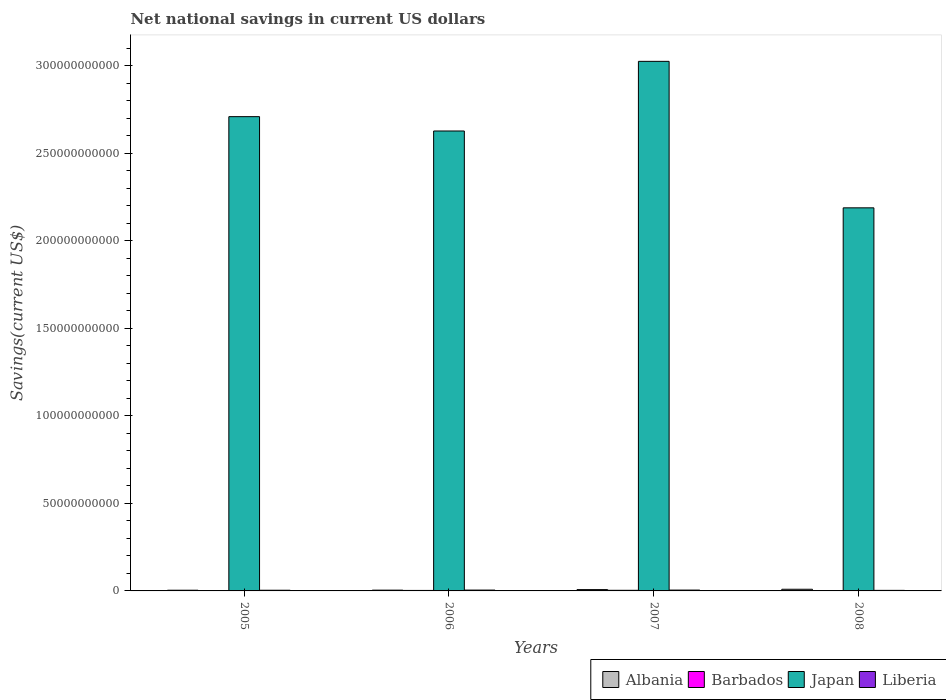How many different coloured bars are there?
Make the answer very short. 4. Are the number of bars per tick equal to the number of legend labels?
Offer a terse response. Yes. How many bars are there on the 1st tick from the left?
Give a very brief answer. 4. How many bars are there on the 3rd tick from the right?
Your answer should be very brief. 4. What is the label of the 3rd group of bars from the left?
Your response must be concise. 2007. In how many cases, is the number of bars for a given year not equal to the number of legend labels?
Your answer should be very brief. 0. What is the net national savings in Liberia in 2008?
Your answer should be very brief. 3.15e+08. Across all years, what is the maximum net national savings in Japan?
Offer a terse response. 3.03e+11. Across all years, what is the minimum net national savings in Albania?
Your response must be concise. 3.93e+08. What is the total net national savings in Japan in the graph?
Offer a terse response. 1.06e+12. What is the difference between the net national savings in Liberia in 2006 and that in 2007?
Offer a very short reply. 1.03e+06. What is the difference between the net national savings in Albania in 2007 and the net national savings in Liberia in 2006?
Your response must be concise. 2.70e+08. What is the average net national savings in Barbados per year?
Offer a terse response. 2.28e+08. In the year 2006, what is the difference between the net national savings in Barbados and net national savings in Liberia?
Your answer should be very brief. -1.98e+08. In how many years, is the net national savings in Japan greater than 160000000000 US$?
Ensure brevity in your answer.  4. What is the ratio of the net national savings in Japan in 2007 to that in 2008?
Your answer should be very brief. 1.38. Is the difference between the net national savings in Barbados in 2005 and 2007 greater than the difference between the net national savings in Liberia in 2005 and 2007?
Your answer should be compact. No. What is the difference between the highest and the second highest net national savings in Liberia?
Your response must be concise. 1.03e+06. What is the difference between the highest and the lowest net national savings in Albania?
Your response must be concise. 5.57e+08. What does the 3rd bar from the left in 2007 represents?
Offer a very short reply. Japan. What does the 1st bar from the right in 2005 represents?
Offer a very short reply. Liberia. Is it the case that in every year, the sum of the net national savings in Liberia and net national savings in Albania is greater than the net national savings in Barbados?
Make the answer very short. Yes. How many bars are there?
Ensure brevity in your answer.  16. How many years are there in the graph?
Provide a succinct answer. 4. What is the difference between two consecutive major ticks on the Y-axis?
Your response must be concise. 5.00e+1. Are the values on the major ticks of Y-axis written in scientific E-notation?
Your answer should be compact. No. Does the graph contain any zero values?
Offer a terse response. No. Does the graph contain grids?
Make the answer very short. No. Where does the legend appear in the graph?
Offer a very short reply. Bottom right. How many legend labels are there?
Give a very brief answer. 4. How are the legend labels stacked?
Your response must be concise. Horizontal. What is the title of the graph?
Make the answer very short. Net national savings in current US dollars. Does "Dominica" appear as one of the legend labels in the graph?
Ensure brevity in your answer.  No. What is the label or title of the X-axis?
Provide a short and direct response. Years. What is the label or title of the Y-axis?
Make the answer very short. Savings(current US$). What is the Savings(current US$) in Albania in 2005?
Offer a very short reply. 3.93e+08. What is the Savings(current US$) in Barbados in 2005?
Provide a short and direct response. 1.75e+08. What is the Savings(current US$) in Japan in 2005?
Offer a very short reply. 2.71e+11. What is the Savings(current US$) in Liberia in 2005?
Your response must be concise. 3.86e+08. What is the Savings(current US$) in Albania in 2006?
Provide a short and direct response. 4.37e+08. What is the Savings(current US$) in Barbados in 2006?
Your answer should be very brief. 2.84e+08. What is the Savings(current US$) of Japan in 2006?
Provide a short and direct response. 2.63e+11. What is the Savings(current US$) in Liberia in 2006?
Offer a very short reply. 4.81e+08. What is the Savings(current US$) of Albania in 2007?
Keep it short and to the point. 7.51e+08. What is the Savings(current US$) in Barbados in 2007?
Offer a terse response. 3.56e+08. What is the Savings(current US$) of Japan in 2007?
Give a very brief answer. 3.03e+11. What is the Savings(current US$) of Liberia in 2007?
Make the answer very short. 4.80e+08. What is the Savings(current US$) in Albania in 2008?
Offer a very short reply. 9.50e+08. What is the Savings(current US$) in Barbados in 2008?
Your response must be concise. 9.70e+07. What is the Savings(current US$) of Japan in 2008?
Provide a short and direct response. 2.19e+11. What is the Savings(current US$) of Liberia in 2008?
Give a very brief answer. 3.15e+08. Across all years, what is the maximum Savings(current US$) in Albania?
Make the answer very short. 9.50e+08. Across all years, what is the maximum Savings(current US$) of Barbados?
Offer a very short reply. 3.56e+08. Across all years, what is the maximum Savings(current US$) of Japan?
Offer a very short reply. 3.03e+11. Across all years, what is the maximum Savings(current US$) of Liberia?
Ensure brevity in your answer.  4.81e+08. Across all years, what is the minimum Savings(current US$) in Albania?
Keep it short and to the point. 3.93e+08. Across all years, what is the minimum Savings(current US$) in Barbados?
Offer a terse response. 9.70e+07. Across all years, what is the minimum Savings(current US$) in Japan?
Offer a very short reply. 2.19e+11. Across all years, what is the minimum Savings(current US$) of Liberia?
Offer a terse response. 3.15e+08. What is the total Savings(current US$) of Albania in the graph?
Your response must be concise. 2.53e+09. What is the total Savings(current US$) in Barbados in the graph?
Your response must be concise. 9.12e+08. What is the total Savings(current US$) of Japan in the graph?
Ensure brevity in your answer.  1.06e+12. What is the total Savings(current US$) in Liberia in the graph?
Provide a short and direct response. 1.66e+09. What is the difference between the Savings(current US$) of Albania in 2005 and that in 2006?
Ensure brevity in your answer.  -4.45e+07. What is the difference between the Savings(current US$) in Barbados in 2005 and that in 2006?
Your answer should be very brief. -1.08e+08. What is the difference between the Savings(current US$) in Japan in 2005 and that in 2006?
Give a very brief answer. 8.19e+09. What is the difference between the Savings(current US$) in Liberia in 2005 and that in 2006?
Give a very brief answer. -9.51e+07. What is the difference between the Savings(current US$) in Albania in 2005 and that in 2007?
Make the answer very short. -3.59e+08. What is the difference between the Savings(current US$) of Barbados in 2005 and that in 2007?
Provide a short and direct response. -1.81e+08. What is the difference between the Savings(current US$) in Japan in 2005 and that in 2007?
Your response must be concise. -3.16e+1. What is the difference between the Savings(current US$) in Liberia in 2005 and that in 2007?
Offer a very short reply. -9.41e+07. What is the difference between the Savings(current US$) of Albania in 2005 and that in 2008?
Provide a succinct answer. -5.57e+08. What is the difference between the Savings(current US$) of Barbados in 2005 and that in 2008?
Keep it short and to the point. 7.85e+07. What is the difference between the Savings(current US$) in Japan in 2005 and that in 2008?
Provide a succinct answer. 5.21e+1. What is the difference between the Savings(current US$) in Liberia in 2005 and that in 2008?
Provide a short and direct response. 7.10e+07. What is the difference between the Savings(current US$) of Albania in 2006 and that in 2007?
Offer a terse response. -3.14e+08. What is the difference between the Savings(current US$) of Barbados in 2006 and that in 2007?
Make the answer very short. -7.25e+07. What is the difference between the Savings(current US$) in Japan in 2006 and that in 2007?
Give a very brief answer. -3.98e+1. What is the difference between the Savings(current US$) in Liberia in 2006 and that in 2007?
Provide a succinct answer. 1.03e+06. What is the difference between the Savings(current US$) of Albania in 2006 and that in 2008?
Your answer should be very brief. -5.13e+08. What is the difference between the Savings(current US$) in Barbados in 2006 and that in 2008?
Your response must be concise. 1.87e+08. What is the difference between the Savings(current US$) of Japan in 2006 and that in 2008?
Offer a terse response. 4.39e+1. What is the difference between the Savings(current US$) in Liberia in 2006 and that in 2008?
Provide a short and direct response. 1.66e+08. What is the difference between the Savings(current US$) of Albania in 2007 and that in 2008?
Make the answer very short. -1.99e+08. What is the difference between the Savings(current US$) of Barbados in 2007 and that in 2008?
Offer a very short reply. 2.59e+08. What is the difference between the Savings(current US$) in Japan in 2007 and that in 2008?
Provide a succinct answer. 8.37e+1. What is the difference between the Savings(current US$) of Liberia in 2007 and that in 2008?
Provide a succinct answer. 1.65e+08. What is the difference between the Savings(current US$) of Albania in 2005 and the Savings(current US$) of Barbados in 2006?
Ensure brevity in your answer.  1.09e+08. What is the difference between the Savings(current US$) in Albania in 2005 and the Savings(current US$) in Japan in 2006?
Offer a terse response. -2.62e+11. What is the difference between the Savings(current US$) of Albania in 2005 and the Savings(current US$) of Liberia in 2006?
Your answer should be compact. -8.81e+07. What is the difference between the Savings(current US$) in Barbados in 2005 and the Savings(current US$) in Japan in 2006?
Provide a succinct answer. -2.63e+11. What is the difference between the Savings(current US$) of Barbados in 2005 and the Savings(current US$) of Liberia in 2006?
Your answer should be very brief. -3.06e+08. What is the difference between the Savings(current US$) in Japan in 2005 and the Savings(current US$) in Liberia in 2006?
Offer a very short reply. 2.71e+11. What is the difference between the Savings(current US$) of Albania in 2005 and the Savings(current US$) of Barbados in 2007?
Offer a terse response. 3.69e+07. What is the difference between the Savings(current US$) of Albania in 2005 and the Savings(current US$) of Japan in 2007?
Offer a terse response. -3.02e+11. What is the difference between the Savings(current US$) of Albania in 2005 and the Savings(current US$) of Liberia in 2007?
Provide a succinct answer. -8.71e+07. What is the difference between the Savings(current US$) of Barbados in 2005 and the Savings(current US$) of Japan in 2007?
Keep it short and to the point. -3.02e+11. What is the difference between the Savings(current US$) of Barbados in 2005 and the Savings(current US$) of Liberia in 2007?
Your response must be concise. -3.05e+08. What is the difference between the Savings(current US$) in Japan in 2005 and the Savings(current US$) in Liberia in 2007?
Your response must be concise. 2.71e+11. What is the difference between the Savings(current US$) in Albania in 2005 and the Savings(current US$) in Barbados in 2008?
Your answer should be compact. 2.96e+08. What is the difference between the Savings(current US$) of Albania in 2005 and the Savings(current US$) of Japan in 2008?
Offer a terse response. -2.19e+11. What is the difference between the Savings(current US$) of Albania in 2005 and the Savings(current US$) of Liberia in 2008?
Make the answer very short. 7.80e+07. What is the difference between the Savings(current US$) of Barbados in 2005 and the Savings(current US$) of Japan in 2008?
Offer a terse response. -2.19e+11. What is the difference between the Savings(current US$) of Barbados in 2005 and the Savings(current US$) of Liberia in 2008?
Ensure brevity in your answer.  -1.40e+08. What is the difference between the Savings(current US$) of Japan in 2005 and the Savings(current US$) of Liberia in 2008?
Keep it short and to the point. 2.71e+11. What is the difference between the Savings(current US$) of Albania in 2006 and the Savings(current US$) of Barbados in 2007?
Give a very brief answer. 8.15e+07. What is the difference between the Savings(current US$) of Albania in 2006 and the Savings(current US$) of Japan in 2007?
Give a very brief answer. -3.02e+11. What is the difference between the Savings(current US$) in Albania in 2006 and the Savings(current US$) in Liberia in 2007?
Your response must be concise. -4.26e+07. What is the difference between the Savings(current US$) in Barbados in 2006 and the Savings(current US$) in Japan in 2007?
Ensure brevity in your answer.  -3.02e+11. What is the difference between the Savings(current US$) in Barbados in 2006 and the Savings(current US$) in Liberia in 2007?
Ensure brevity in your answer.  -1.96e+08. What is the difference between the Savings(current US$) of Japan in 2006 and the Savings(current US$) of Liberia in 2007?
Offer a very short reply. 2.62e+11. What is the difference between the Savings(current US$) of Albania in 2006 and the Savings(current US$) of Barbados in 2008?
Make the answer very short. 3.41e+08. What is the difference between the Savings(current US$) in Albania in 2006 and the Savings(current US$) in Japan in 2008?
Ensure brevity in your answer.  -2.18e+11. What is the difference between the Savings(current US$) of Albania in 2006 and the Savings(current US$) of Liberia in 2008?
Your answer should be compact. 1.22e+08. What is the difference between the Savings(current US$) in Barbados in 2006 and the Savings(current US$) in Japan in 2008?
Your answer should be very brief. -2.19e+11. What is the difference between the Savings(current US$) in Barbados in 2006 and the Savings(current US$) in Liberia in 2008?
Give a very brief answer. -3.14e+07. What is the difference between the Savings(current US$) of Japan in 2006 and the Savings(current US$) of Liberia in 2008?
Offer a very short reply. 2.63e+11. What is the difference between the Savings(current US$) in Albania in 2007 and the Savings(current US$) in Barbados in 2008?
Give a very brief answer. 6.54e+08. What is the difference between the Savings(current US$) of Albania in 2007 and the Savings(current US$) of Japan in 2008?
Your answer should be very brief. -2.18e+11. What is the difference between the Savings(current US$) in Albania in 2007 and the Savings(current US$) in Liberia in 2008?
Make the answer very short. 4.36e+08. What is the difference between the Savings(current US$) of Barbados in 2007 and the Savings(current US$) of Japan in 2008?
Your answer should be compact. -2.19e+11. What is the difference between the Savings(current US$) in Barbados in 2007 and the Savings(current US$) in Liberia in 2008?
Provide a short and direct response. 4.10e+07. What is the difference between the Savings(current US$) in Japan in 2007 and the Savings(current US$) in Liberia in 2008?
Your response must be concise. 3.02e+11. What is the average Savings(current US$) of Albania per year?
Ensure brevity in your answer.  6.33e+08. What is the average Savings(current US$) in Barbados per year?
Your response must be concise. 2.28e+08. What is the average Savings(current US$) in Japan per year?
Offer a very short reply. 2.64e+11. What is the average Savings(current US$) of Liberia per year?
Offer a terse response. 4.16e+08. In the year 2005, what is the difference between the Savings(current US$) of Albania and Savings(current US$) of Barbados?
Provide a succinct answer. 2.17e+08. In the year 2005, what is the difference between the Savings(current US$) of Albania and Savings(current US$) of Japan?
Give a very brief answer. -2.71e+11. In the year 2005, what is the difference between the Savings(current US$) of Albania and Savings(current US$) of Liberia?
Ensure brevity in your answer.  6.98e+06. In the year 2005, what is the difference between the Savings(current US$) in Barbados and Savings(current US$) in Japan?
Your response must be concise. -2.71e+11. In the year 2005, what is the difference between the Savings(current US$) of Barbados and Savings(current US$) of Liberia?
Keep it short and to the point. -2.10e+08. In the year 2005, what is the difference between the Savings(current US$) in Japan and Savings(current US$) in Liberia?
Your answer should be very brief. 2.71e+11. In the year 2006, what is the difference between the Savings(current US$) in Albania and Savings(current US$) in Barbados?
Your answer should be compact. 1.54e+08. In the year 2006, what is the difference between the Savings(current US$) of Albania and Savings(current US$) of Japan?
Your answer should be very brief. -2.62e+11. In the year 2006, what is the difference between the Savings(current US$) in Albania and Savings(current US$) in Liberia?
Provide a short and direct response. -4.36e+07. In the year 2006, what is the difference between the Savings(current US$) of Barbados and Savings(current US$) of Japan?
Your response must be concise. -2.63e+11. In the year 2006, what is the difference between the Savings(current US$) in Barbados and Savings(current US$) in Liberia?
Make the answer very short. -1.98e+08. In the year 2006, what is the difference between the Savings(current US$) in Japan and Savings(current US$) in Liberia?
Provide a short and direct response. 2.62e+11. In the year 2007, what is the difference between the Savings(current US$) in Albania and Savings(current US$) in Barbados?
Provide a short and direct response. 3.95e+08. In the year 2007, what is the difference between the Savings(current US$) in Albania and Savings(current US$) in Japan?
Your answer should be compact. -3.02e+11. In the year 2007, what is the difference between the Savings(current US$) of Albania and Savings(current US$) of Liberia?
Keep it short and to the point. 2.71e+08. In the year 2007, what is the difference between the Savings(current US$) in Barbados and Savings(current US$) in Japan?
Provide a succinct answer. -3.02e+11. In the year 2007, what is the difference between the Savings(current US$) in Barbados and Savings(current US$) in Liberia?
Keep it short and to the point. -1.24e+08. In the year 2007, what is the difference between the Savings(current US$) in Japan and Savings(current US$) in Liberia?
Offer a very short reply. 3.02e+11. In the year 2008, what is the difference between the Savings(current US$) of Albania and Savings(current US$) of Barbados?
Your answer should be very brief. 8.53e+08. In the year 2008, what is the difference between the Savings(current US$) in Albania and Savings(current US$) in Japan?
Your answer should be very brief. -2.18e+11. In the year 2008, what is the difference between the Savings(current US$) of Albania and Savings(current US$) of Liberia?
Your answer should be very brief. 6.35e+08. In the year 2008, what is the difference between the Savings(current US$) in Barbados and Savings(current US$) in Japan?
Offer a very short reply. -2.19e+11. In the year 2008, what is the difference between the Savings(current US$) in Barbados and Savings(current US$) in Liberia?
Your response must be concise. -2.18e+08. In the year 2008, what is the difference between the Savings(current US$) of Japan and Savings(current US$) of Liberia?
Provide a short and direct response. 2.19e+11. What is the ratio of the Savings(current US$) of Albania in 2005 to that in 2006?
Keep it short and to the point. 0.9. What is the ratio of the Savings(current US$) in Barbados in 2005 to that in 2006?
Keep it short and to the point. 0.62. What is the ratio of the Savings(current US$) of Japan in 2005 to that in 2006?
Provide a succinct answer. 1.03. What is the ratio of the Savings(current US$) of Liberia in 2005 to that in 2006?
Ensure brevity in your answer.  0.8. What is the ratio of the Savings(current US$) in Albania in 2005 to that in 2007?
Keep it short and to the point. 0.52. What is the ratio of the Savings(current US$) in Barbados in 2005 to that in 2007?
Make the answer very short. 0.49. What is the ratio of the Savings(current US$) of Japan in 2005 to that in 2007?
Provide a short and direct response. 0.9. What is the ratio of the Savings(current US$) in Liberia in 2005 to that in 2007?
Make the answer very short. 0.8. What is the ratio of the Savings(current US$) in Albania in 2005 to that in 2008?
Your answer should be very brief. 0.41. What is the ratio of the Savings(current US$) of Barbados in 2005 to that in 2008?
Your answer should be very brief. 1.81. What is the ratio of the Savings(current US$) of Japan in 2005 to that in 2008?
Make the answer very short. 1.24. What is the ratio of the Savings(current US$) in Liberia in 2005 to that in 2008?
Offer a very short reply. 1.23. What is the ratio of the Savings(current US$) of Albania in 2006 to that in 2007?
Your answer should be compact. 0.58. What is the ratio of the Savings(current US$) in Barbados in 2006 to that in 2007?
Make the answer very short. 0.8. What is the ratio of the Savings(current US$) in Japan in 2006 to that in 2007?
Offer a very short reply. 0.87. What is the ratio of the Savings(current US$) in Liberia in 2006 to that in 2007?
Give a very brief answer. 1. What is the ratio of the Savings(current US$) in Albania in 2006 to that in 2008?
Ensure brevity in your answer.  0.46. What is the ratio of the Savings(current US$) of Barbados in 2006 to that in 2008?
Provide a succinct answer. 2.92. What is the ratio of the Savings(current US$) in Japan in 2006 to that in 2008?
Your answer should be very brief. 1.2. What is the ratio of the Savings(current US$) of Liberia in 2006 to that in 2008?
Ensure brevity in your answer.  1.53. What is the ratio of the Savings(current US$) of Albania in 2007 to that in 2008?
Provide a succinct answer. 0.79. What is the ratio of the Savings(current US$) of Barbados in 2007 to that in 2008?
Ensure brevity in your answer.  3.67. What is the ratio of the Savings(current US$) of Japan in 2007 to that in 2008?
Your answer should be very brief. 1.38. What is the ratio of the Savings(current US$) of Liberia in 2007 to that in 2008?
Make the answer very short. 1.52. What is the difference between the highest and the second highest Savings(current US$) of Albania?
Offer a terse response. 1.99e+08. What is the difference between the highest and the second highest Savings(current US$) of Barbados?
Give a very brief answer. 7.25e+07. What is the difference between the highest and the second highest Savings(current US$) in Japan?
Your answer should be compact. 3.16e+1. What is the difference between the highest and the second highest Savings(current US$) in Liberia?
Provide a short and direct response. 1.03e+06. What is the difference between the highest and the lowest Savings(current US$) of Albania?
Offer a very short reply. 5.57e+08. What is the difference between the highest and the lowest Savings(current US$) of Barbados?
Offer a very short reply. 2.59e+08. What is the difference between the highest and the lowest Savings(current US$) in Japan?
Keep it short and to the point. 8.37e+1. What is the difference between the highest and the lowest Savings(current US$) of Liberia?
Ensure brevity in your answer.  1.66e+08. 